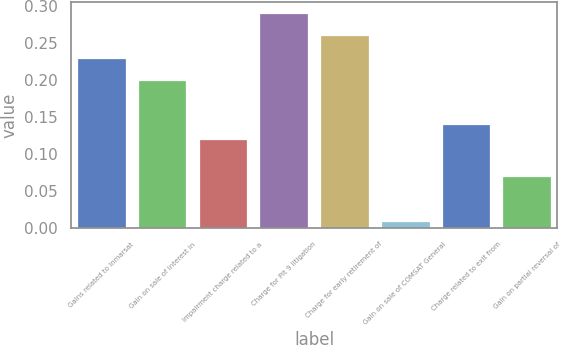Convert chart. <chart><loc_0><loc_0><loc_500><loc_500><bar_chart><fcel>Gains related to Inmarsat<fcel>Gain on sale of interest in<fcel>Impairment charge related to a<fcel>Charge for Pit 9 litigation<fcel>Charge for early retirement of<fcel>Gain on sale of COMSAT General<fcel>Charge related to exit from<fcel>Gain on partial reversal of<nl><fcel>0.23<fcel>0.2<fcel>0.12<fcel>0.29<fcel>0.26<fcel>0.01<fcel>0.14<fcel>0.07<nl></chart> 